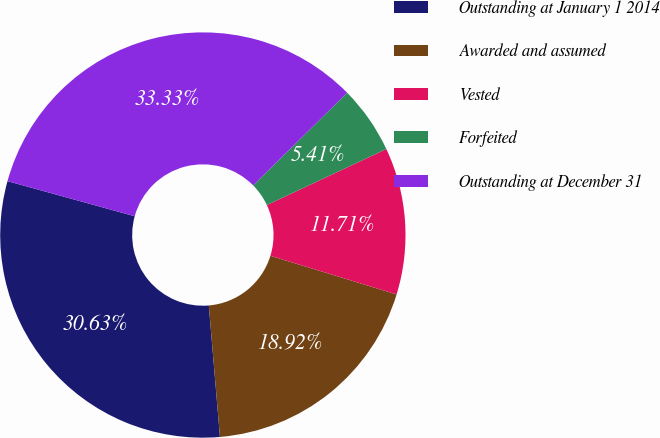<chart> <loc_0><loc_0><loc_500><loc_500><pie_chart><fcel>Outstanding at January 1 2014<fcel>Awarded and assumed<fcel>Vested<fcel>Forfeited<fcel>Outstanding at December 31<nl><fcel>30.63%<fcel>18.92%<fcel>11.71%<fcel>5.41%<fcel>33.33%<nl></chart> 